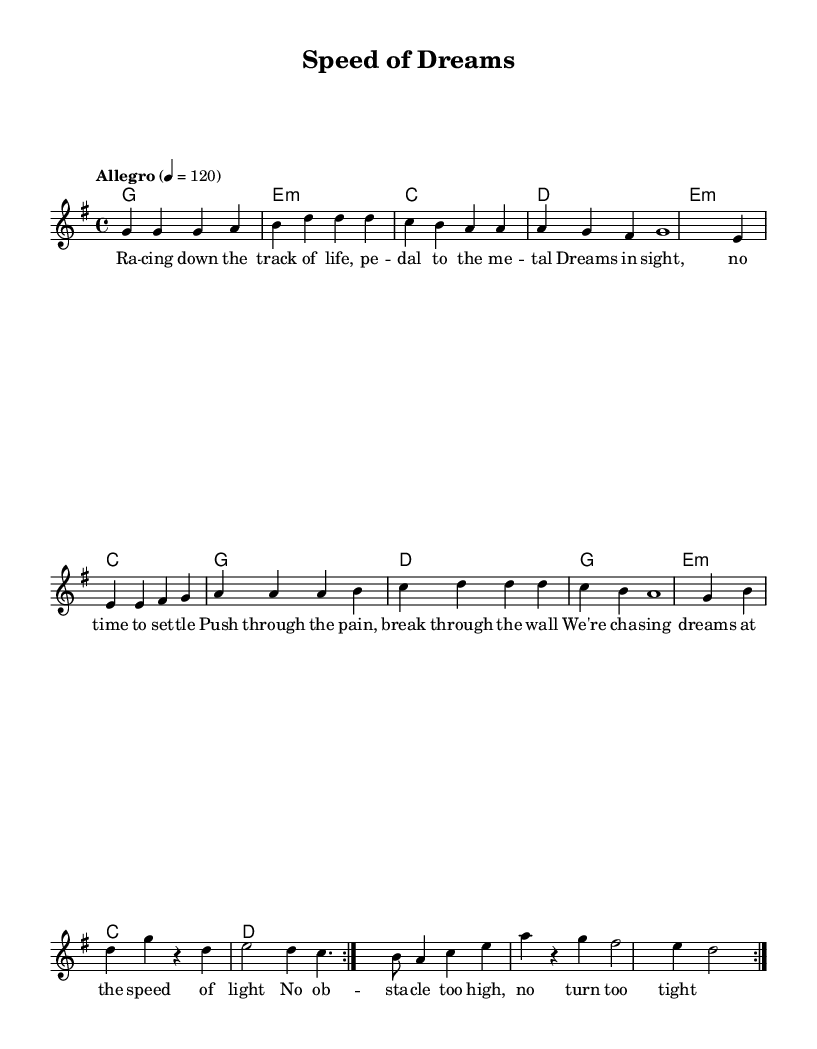What is the key signature of this music? The key signature indicated is G major, which contains one sharp (F#). This can be identified at the beginning of the staff where the key signature is shown.
Answer: G major What is the time signature of this piece? The time signature is displayed at the beginning of the score as 4/4, which represents four beats in a measure and a quarter note gets one beat.
Answer: 4/4 What is the tempo marking of the song? The tempo marking is indicated as "Allegro" with a metronome mark of 120 beats per minute, which suggests a lively and fast pace for the music.
Answer: Allegro, 120 How many times is the melody repeated in the piece? The melody is marked with the instruction "repeat volta 2", indicating that the melodic section is intended to be played two times in total.
Answer: 2 Which note is held for the longest duration in the first melody section? In the first melody section, the note G in the last measure of the first repeat is held for a whole note duration (1). This is indicated by the notation of the note lasting the entire measure.
Answer: G What lyrical theme is presented in the first verse? The lyrics emphasize the themes of perseverance and chasing dreams, as shown by phrases like "chasing dreams at the speed of light" and "no obstacle too high." This reflects the song’s message of overcoming challenges.
Answer: Perseverance and dreams What kind of chord progression is primarily used in the piece? The primary chord progression follows a I-vi-IV-V pattern throughout, commonly used in R&B music. The chords G, e minor, C, and D are consistently repeated in a cyclical manner.
Answer: I-vi-IV-V 